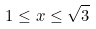<formula> <loc_0><loc_0><loc_500><loc_500>1 \leq x \leq \sqrt { 3 }</formula> 